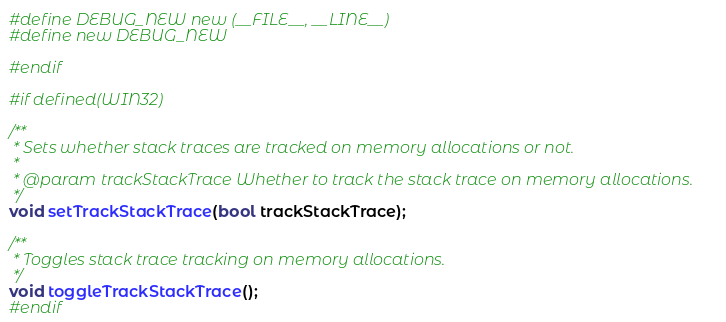<code> <loc_0><loc_0><loc_500><loc_500><_C_>#define DEBUG_NEW new (__FILE__, __LINE__)
#define new DEBUG_NEW

#endif

#if defined(WIN32)

/**
 * Sets whether stack traces are tracked on memory allocations or not.
 * 
 * @param trackStackTrace Whether to track the stack trace on memory allocations.
 */
void setTrackStackTrace(bool trackStackTrace);

/**
 * Toggles stack trace tracking on memory allocations.
 */
void toggleTrackStackTrace();
#endif
</code> 